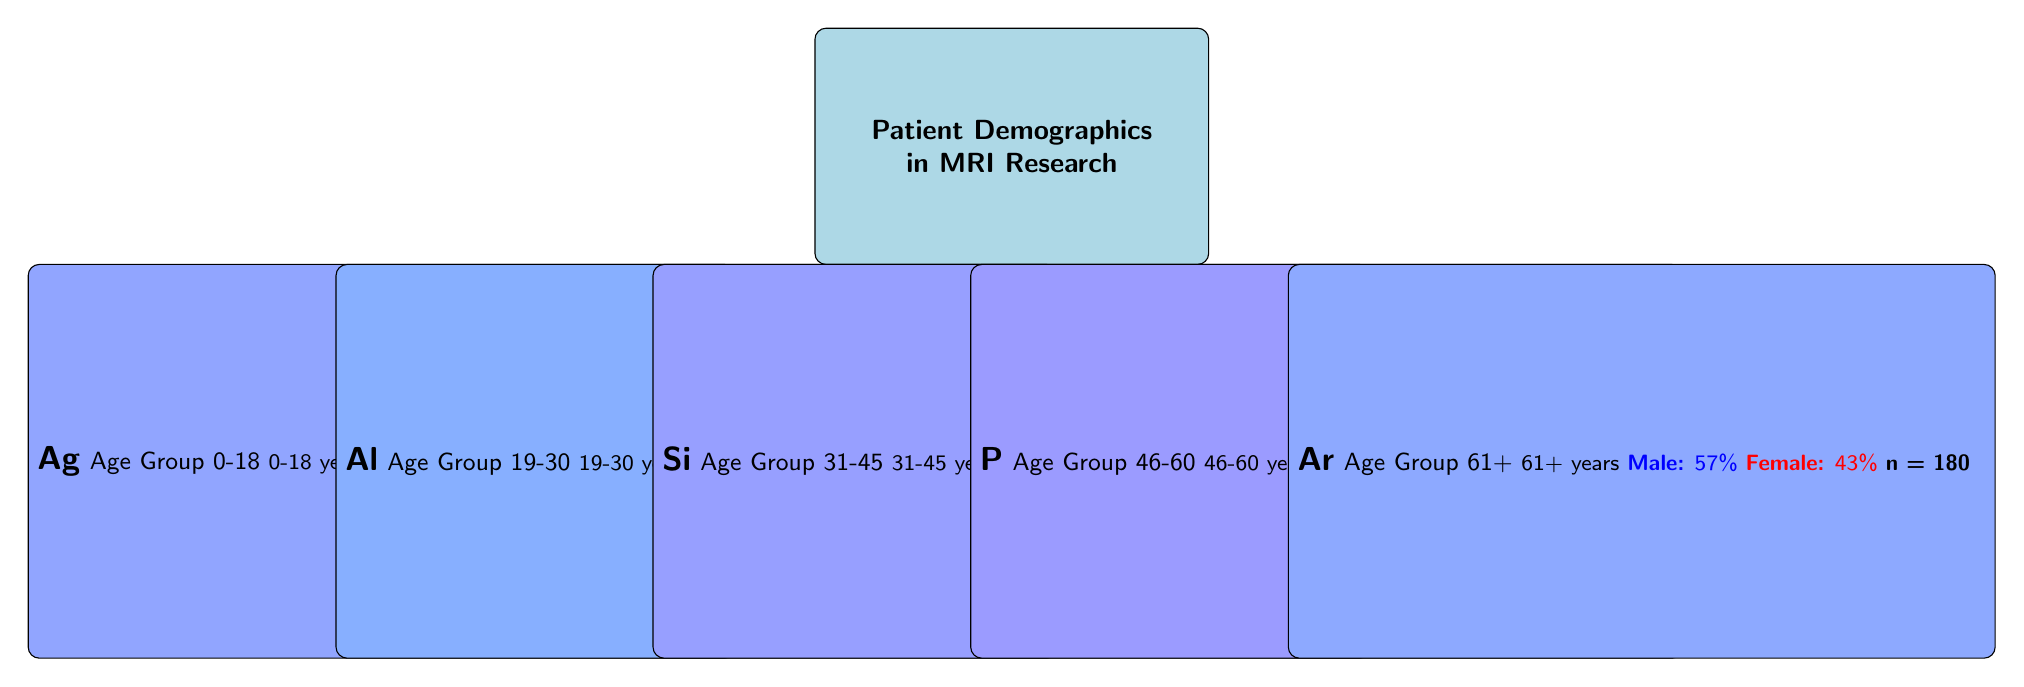What is the sample size for the age group 46-60? Referring to the table, the sample size for the age group 46-60 is listed as 300.
Answer: 300 Which age group has the highest percentage of male patients? Looking at the MalePercentage column, the age group 19-30 has the highest percentage at 60%.
Answer: Age Group 19-30 Is the percentage of female patients in the age group 61+ greater than that in the age group 31-45? The FemalePercentage for age group 61+ is 43% and for age group 31-45 it is 48%. Since 48% is greater than 43%, the statement is false.
Answer: No What is the average male percentage across all age groups? To find the average, sum the male percentages: (55 + 60 + 52 + 50 + 57) = 274. Divide by the number of age groups (5): 274/5 = 54.8.
Answer: 54.8 How many total patients were surveyed across all age groups? By summing the SampleSize for each age group, we have: 120 + 200 + 250 + 300 + 180 = 1050.
Answer: 1050 Does the age group 0-18 have a higher percentage of females than the age group 46-60? The FemalePercentage for age group 0-18 is 45%, while for age group 46-60 it is 50%. Since 50% is greater, the answer is yes.
Answer: Yes Which age group has the closest distribution of male and female percentages? The age group 46-60 has both male and female percentages at 50%, indicating a perfect distribution.
Answer: Age Group 46-60 What is the combined male percentage for age groups 0-18 and 61+? The combined male percentage for age groups 0-18 (55%) and 61+ (57%) is 55 + 57 = 112.
Answer: 112 Is the percentage of male patients in the age group 31-45 less than that in the age group 19-30? The MalePercentage in age group 31-45 is 52% while in age group 19-30 it is 60%. Since 52% is less, the answer is yes.
Answer: Yes 